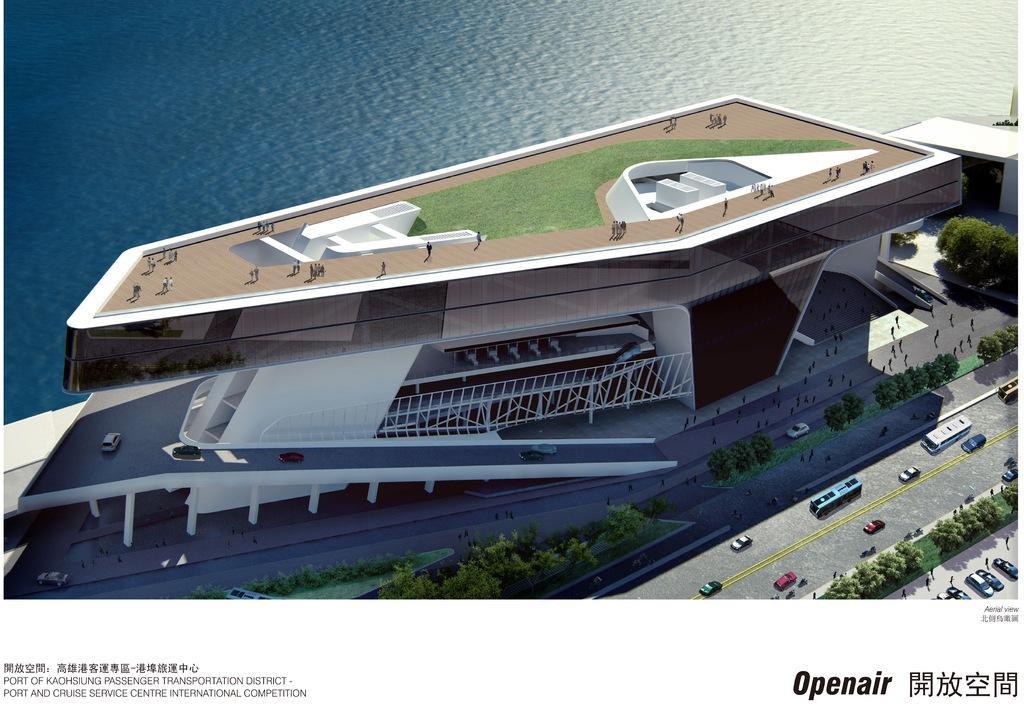How would you summarize this image in a sentence or two? This is an advertisement. This is an aerial view. In this picture we can see the buildings, grass, trees, vehicles, road, pillars and some people are walking on the road and some of them are floor. At the top of the image we can see the water. At the bottom of the image we can see the text. 